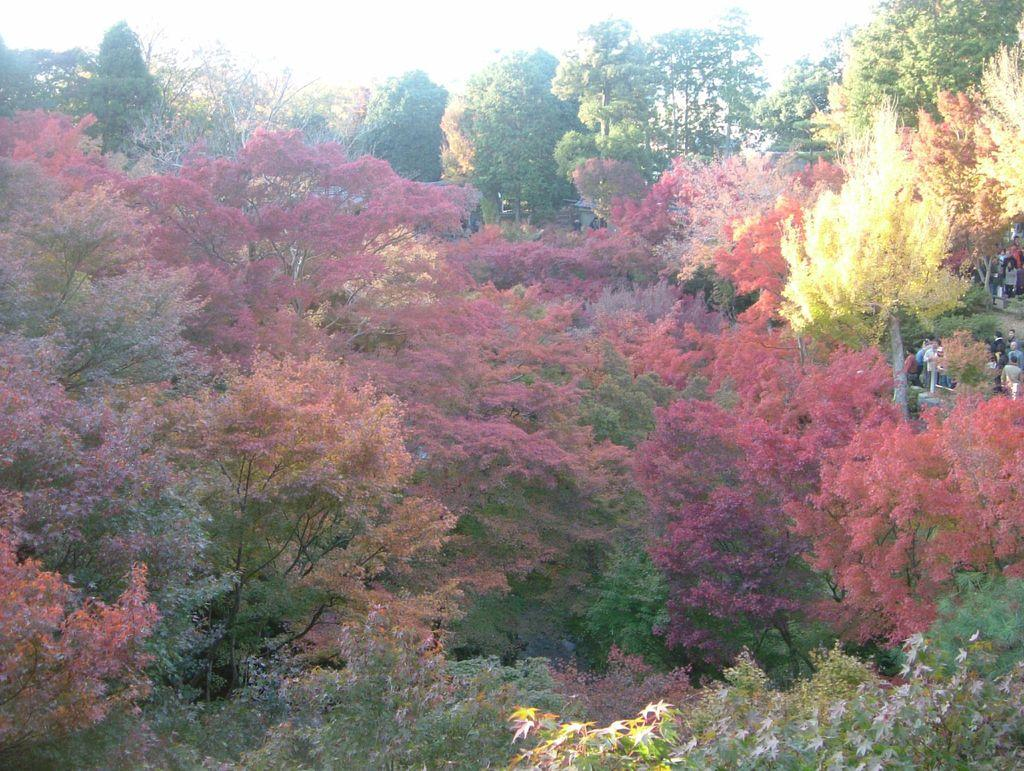What type of vegetation is in the foreground of the image? There are trees in the foreground of the image. What is visible at the top of the image? The sky is visible at the top of the image. Where are the people located in the image? The people are on the right side of the image. What is the tendency of the yam in the image? There is no yam present in the image, so it is not possible to determine its tendency. What type of test is being conducted in the image? There is no test being conducted in the image; it features trees, the sky, and people. 